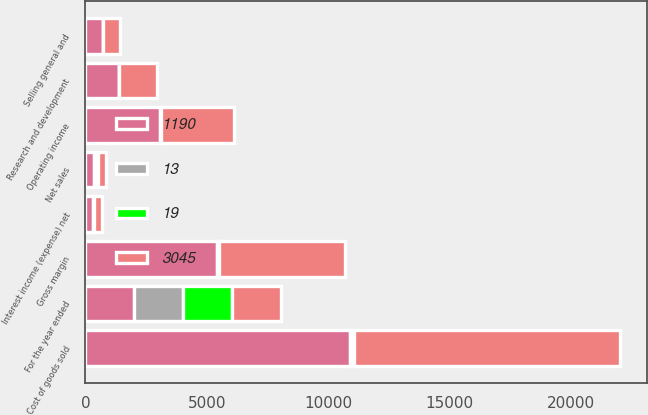Convert chart to OTSL. <chart><loc_0><loc_0><loc_500><loc_500><stacked_bar_chart><ecel><fcel>For the year ended<fcel>Net sales<fcel>Cost of goods sold<fcel>Gross margin<fcel>Selling general and<fcel>Research and development<fcel>Operating income<fcel>Interest income (expense) net<nl><fcel>3045<fcel>2015<fcel>332.5<fcel>10977<fcel>5215<fcel>719<fcel>1540<fcel>2998<fcel>336<nl><fcel>19<fcel>2015<fcel>100<fcel>68<fcel>32<fcel>4<fcel>10<fcel>19<fcel>2<nl><fcel>1190<fcel>2014<fcel>332.5<fcel>10921<fcel>5437<fcel>707<fcel>1371<fcel>3087<fcel>329<nl><fcel>13<fcel>2014<fcel>100<fcel>67<fcel>33<fcel>4<fcel>8<fcel>19<fcel>2<nl></chart> 